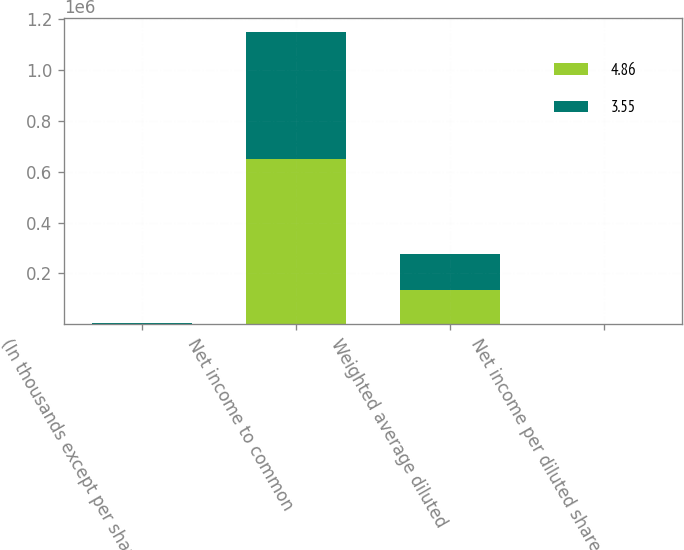Convert chart. <chart><loc_0><loc_0><loc_500><loc_500><stacked_bar_chart><ecel><fcel>(In thousands except per share<fcel>Net income to common<fcel>Weighted average diluted<fcel>Net income per diluted share<nl><fcel>4.86<fcel>2014<fcel>648884<fcel>133652<fcel>4.86<nl><fcel>3.55<fcel>2013<fcel>499925<fcel>140743<fcel>3.55<nl></chart> 